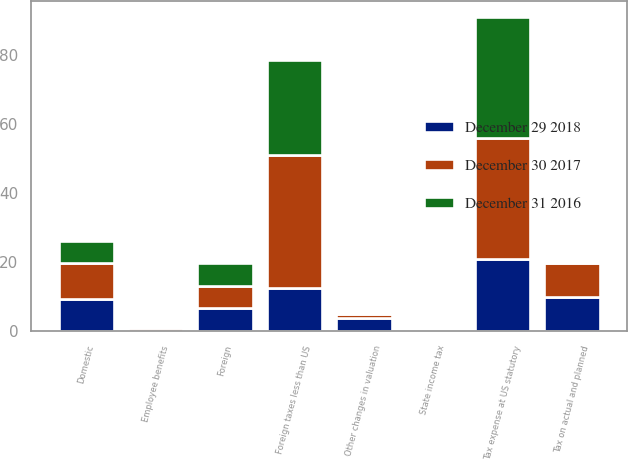Convert chart to OTSL. <chart><loc_0><loc_0><loc_500><loc_500><stacked_bar_chart><ecel><fcel>Domestic<fcel>Foreign<fcel>Tax expense at US statutory<fcel>State income tax<fcel>Tax on actual and planned<fcel>Foreign taxes less than US<fcel>Employee benefits<fcel>Other changes in valuation<nl><fcel>December 29 2018<fcel>9.4<fcel>6.6<fcel>21<fcel>0.3<fcel>9.8<fcel>12.6<fcel>0.1<fcel>3.9<nl><fcel>December 31 2016<fcel>6.6<fcel>6.6<fcel>35<fcel>0.2<fcel>0.5<fcel>27.4<fcel>0.2<fcel>0.1<nl><fcel>December 30 2017<fcel>10.2<fcel>6.6<fcel>35<fcel>0.7<fcel>9.9<fcel>38.5<fcel>0.7<fcel>1.2<nl></chart> 